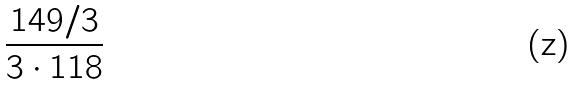<formula> <loc_0><loc_0><loc_500><loc_500>\frac { 1 4 9 / 3 } { 3 \cdot 1 1 8 }</formula> 